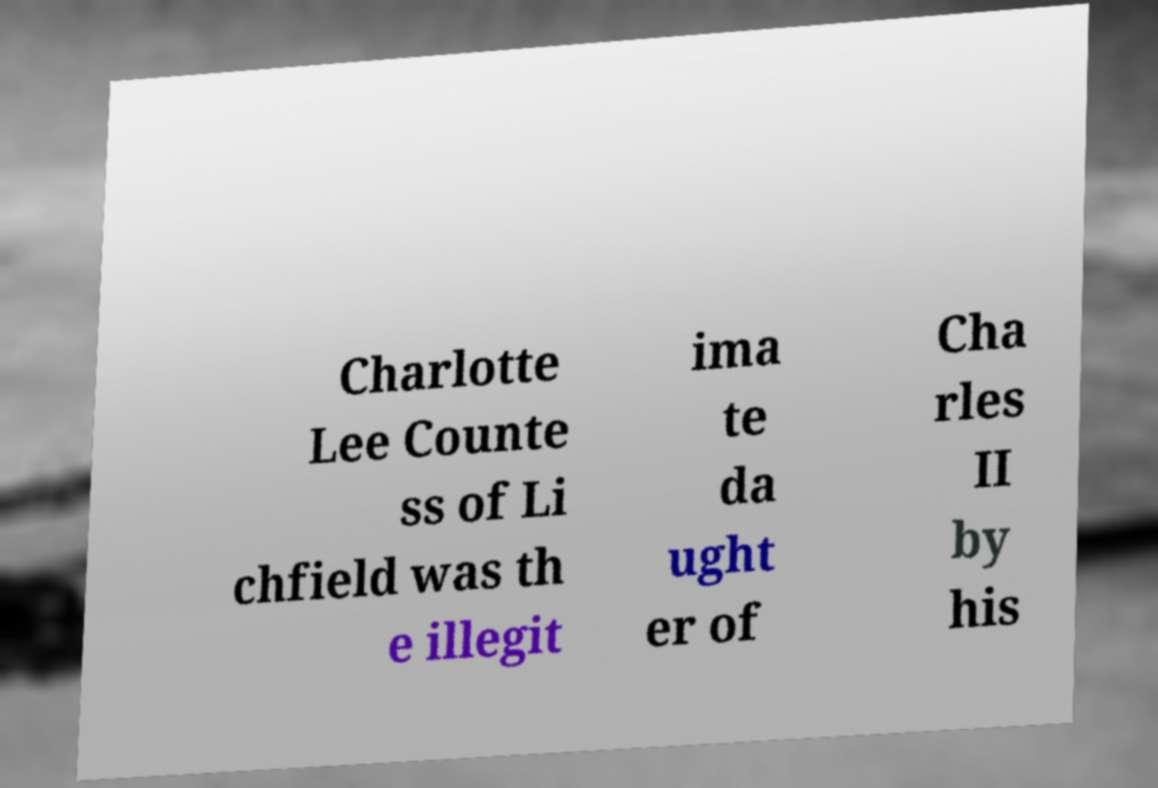Can you accurately transcribe the text from the provided image for me? Charlotte Lee Counte ss of Li chfield was th e illegit ima te da ught er of Cha rles II by his 